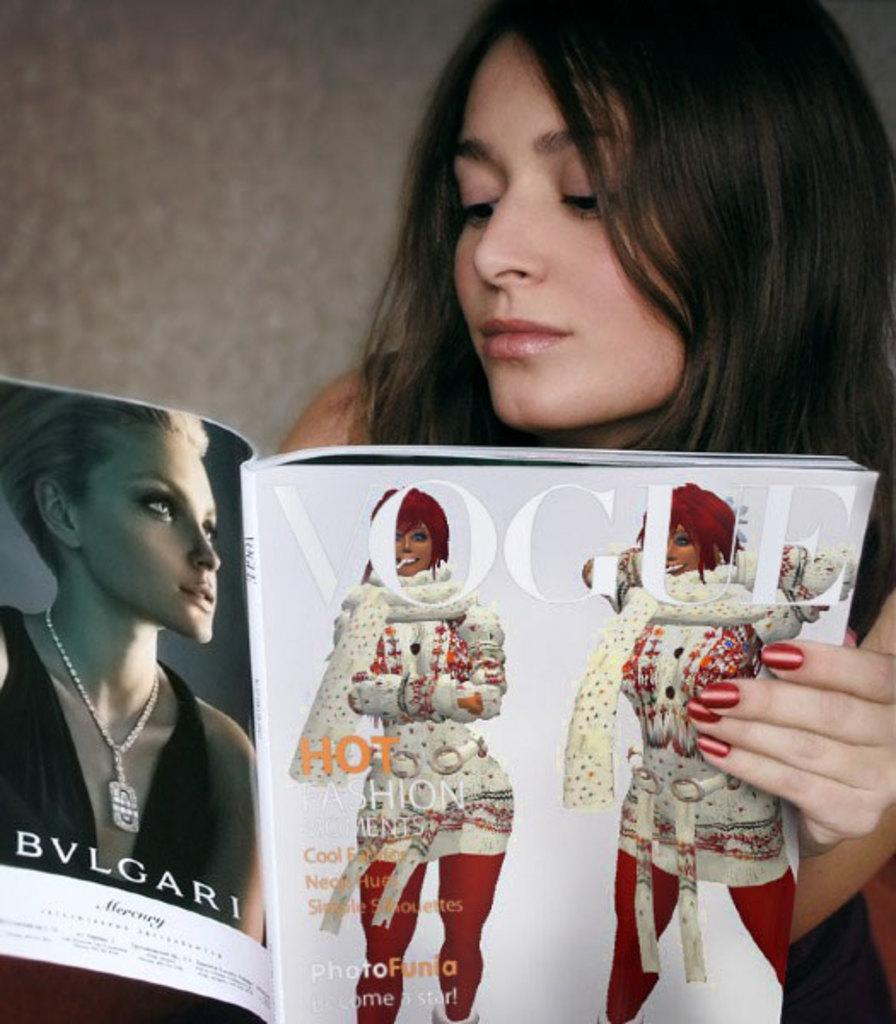Who is the main subject in the image? There is a woman in the image. What is the woman doing in the image? The woman is looking at a magazine. What can be seen on the woman's nails? The woman has red paint on her nails. What is visible behind the woman in the image? There is a wall behind the woman. What type of stem is holding the flowers in the vase on the table? There is no vase or flowers present in the image; it only features a woman looking at a magazine with red paint on her nails and a wall in the background. 